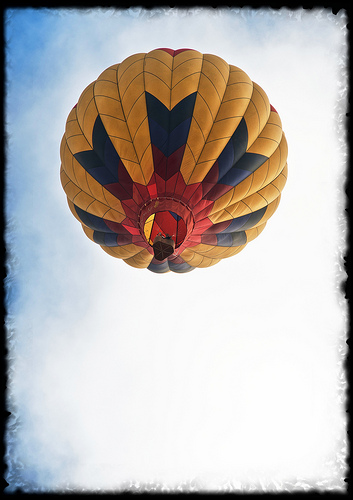<image>
Can you confirm if the balloon is next to the sky? No. The balloon is not positioned next to the sky. They are located in different areas of the scene. 